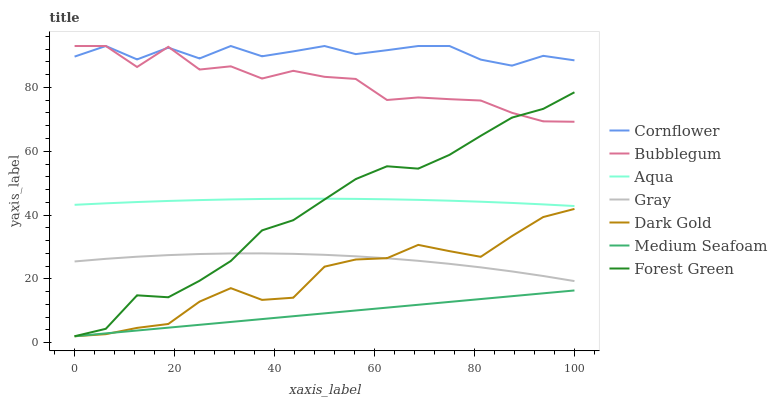Does Medium Seafoam have the minimum area under the curve?
Answer yes or no. Yes. Does Cornflower have the maximum area under the curve?
Answer yes or no. Yes. Does Dark Gold have the minimum area under the curve?
Answer yes or no. No. Does Dark Gold have the maximum area under the curve?
Answer yes or no. No. Is Medium Seafoam the smoothest?
Answer yes or no. Yes. Is Bubblegum the roughest?
Answer yes or no. Yes. Is Dark Gold the smoothest?
Answer yes or no. No. Is Dark Gold the roughest?
Answer yes or no. No. Does Aqua have the lowest value?
Answer yes or no. No. Does Dark Gold have the highest value?
Answer yes or no. No. Is Medium Seafoam less than Cornflower?
Answer yes or no. Yes. Is Gray greater than Medium Seafoam?
Answer yes or no. Yes. Does Medium Seafoam intersect Cornflower?
Answer yes or no. No. 